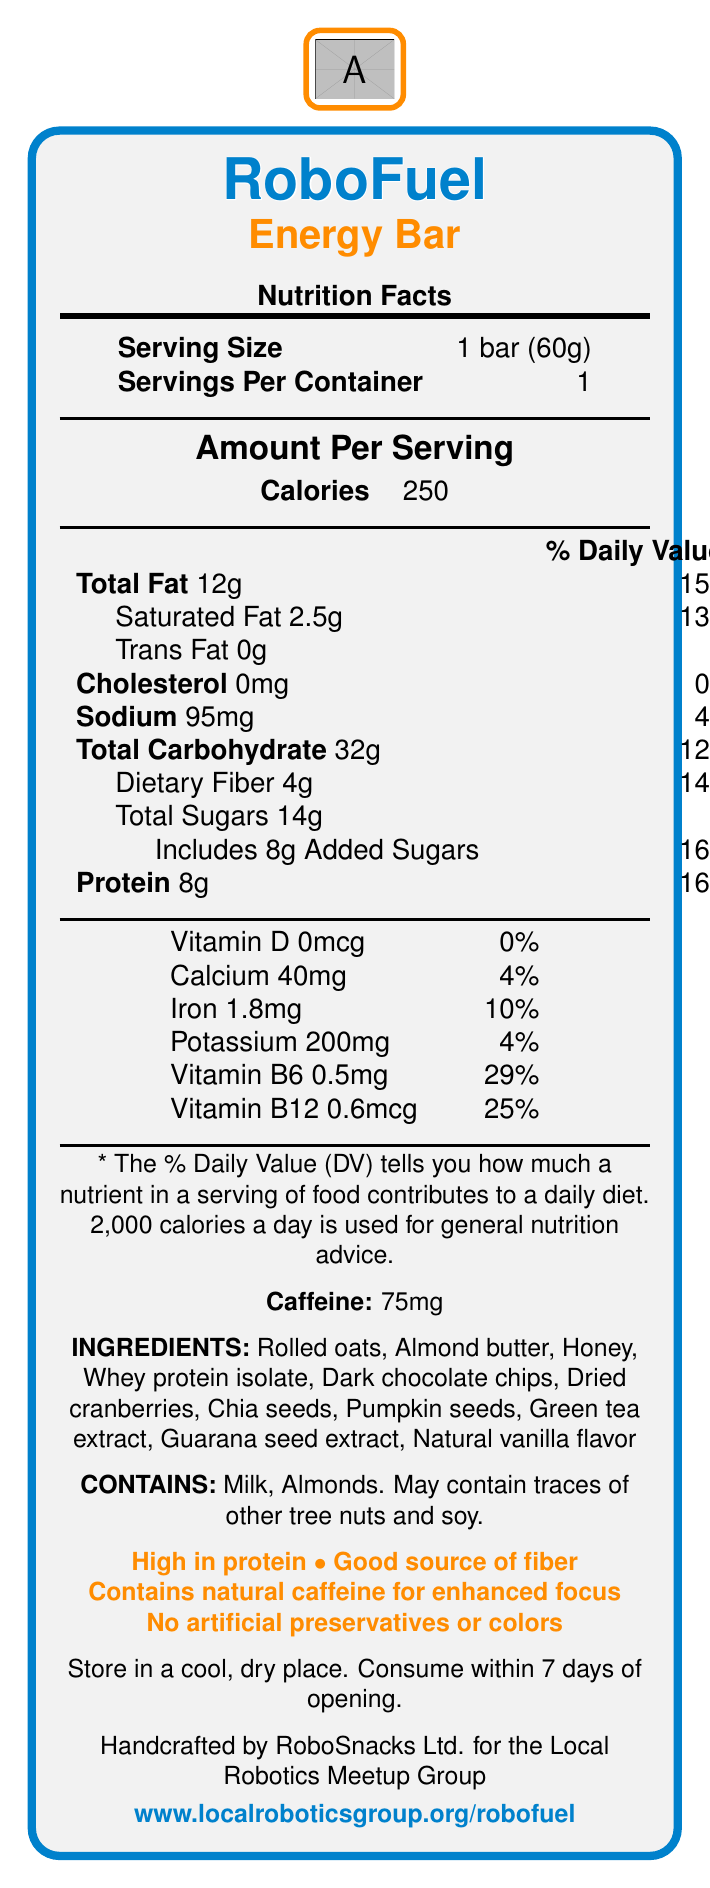what is the serving size of RoboFuel Energy Bar? The serving size is explicitly mentioned in the document.
Answer: 1 bar (60g) how many grams of protein are in one serving? The document lists the amount of protein per serving as 8 grams.
Answer: 8g what percentage of the daily value of saturated fat does one bar contain? The document indicates that one bar contains 2.5 grams of saturated fat, which is 13% of the daily value.
Answer: 13% how much caffeine is in each energy bar? The amount of caffeine is directly mentioned as 75mg per bar.
Answer: 75mg what are the two main fat types listed in the document? The document specifies Total Fat and Saturated Fat as the main fat types.
Answer: Total Fat, Saturated Fat how many total carbohydrates are in one energy bar? The document states that there are 32 grams of total carbohydrates in one bar.
Answer: 32g what are the main ingredients of RoboFuel Energy Bar? A. Almond butter, Honey, Sucrose B. Rolled oats, Almond butter, Honey C. Rolled oats, Sugar, Vanilla The main ingredients listed are Rolled oats, Almond butter, Honey.
Answer: B which vitamin has the highest percentage of daily value in the bar? A. Vitamin D B. Vitamin B6 C. Iron Vitamin B6 is listed with the highest percentage at 29% of the daily value.
Answer: B does RoboFuel Energy Bar contain any artificial preservatives? The document claims "No artificial preservatives or colors", indicating the energy bar does not contain artificial preservatives.
Answer: No is there any dietary fiber in the energy bar? The document lists 4 grams of dietary fiber per serving.
Answer: Yes what is the primary focus of the claims list? The claims list summarizes the main benefits and characteristics of the energy bar, focusing on its nutritional benefits and absence of artificial additives.
Answer: High in protein, Good source of fiber, Contains natural caffeine for enhanced focus, No artificial preservatives or colors is there any way to determine the number of energy bars in a box? The document provides information per bar and per container but does not specify the number of bars in a box.
Answer: Not enough information describe the entire document in a few sentences. The document provides comprehensive nutritional data and other relevant details for the RoboFuel Energy Bar, designed to support robotics enthusiasts during coding sessions.
Answer: The document is a Nutrition Facts Label for RoboFuel Energy Bar. It includes serving size, calories, and nutrient information, along with ingredients and allergen information. It highlights health claims and provides storage instructions. Additionally, there is manufacturer info and a website link for more details. 